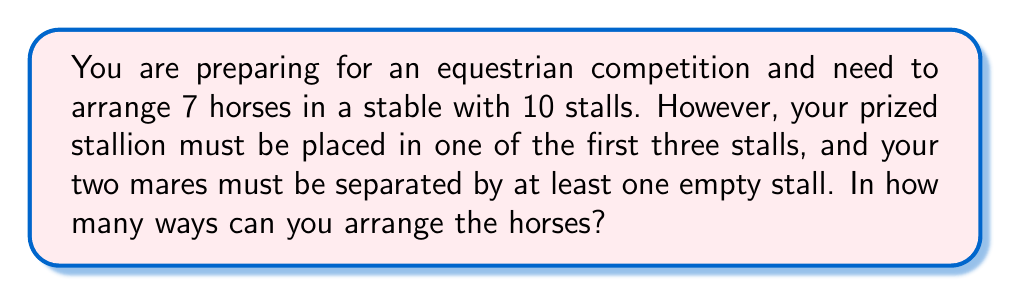Teach me how to tackle this problem. Let's approach this step-by-step:

1) First, let's place the stallion. There are 3 choices for the stallion's stall.

2) Now, we need to arrange the remaining 6 horses (including the two mares) in the remaining 9 stalls.

3) Let's consider the placement of the two mares:
   - They need to be separated by at least one empty stall.
   - We can think of this as placing two objects (the mares) with at least one space between them in a line of 9 positions.
   - This is equivalent to choosing 2 positions out of 8 (we lose one position due to the separation requirement).
   - The number of ways to do this is $\binom{8}{2} = 28$.

4) After placing the mares, we have 4 horses left to arrange in the remaining 7 stalls.
   - This is a combination problem: $\binom{7}{4} = 35$.

5) By the multiplication principle, the total number of arrangements is:
   $$3 \times 28 \times 35 = 2,940$$

Therefore, there are 2,940 ways to arrange the horses according to the given constraints.
Answer: 2,940 